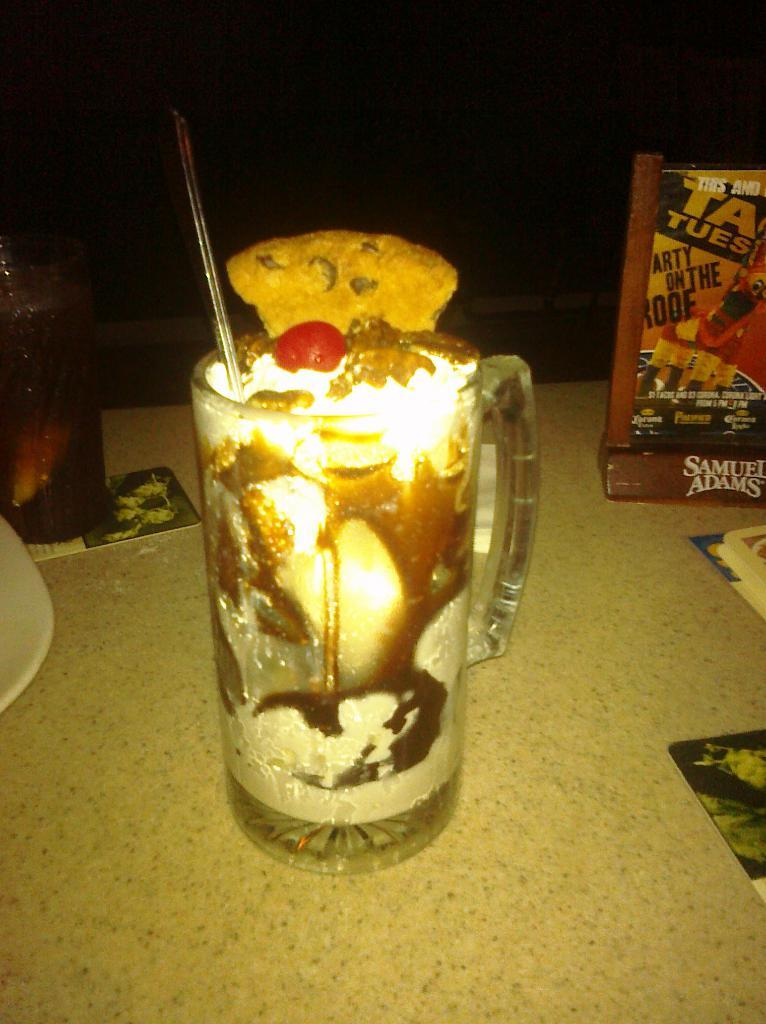<image>
Share a concise interpretation of the image provided. A Samuel Adams sign-holder advertises the restaurant's specials. 